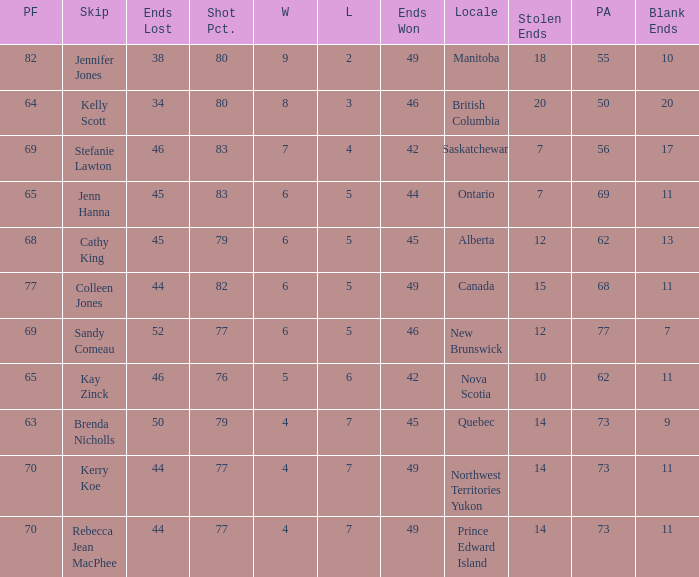What is the minimum PA when ends lost is 45? 62.0. 